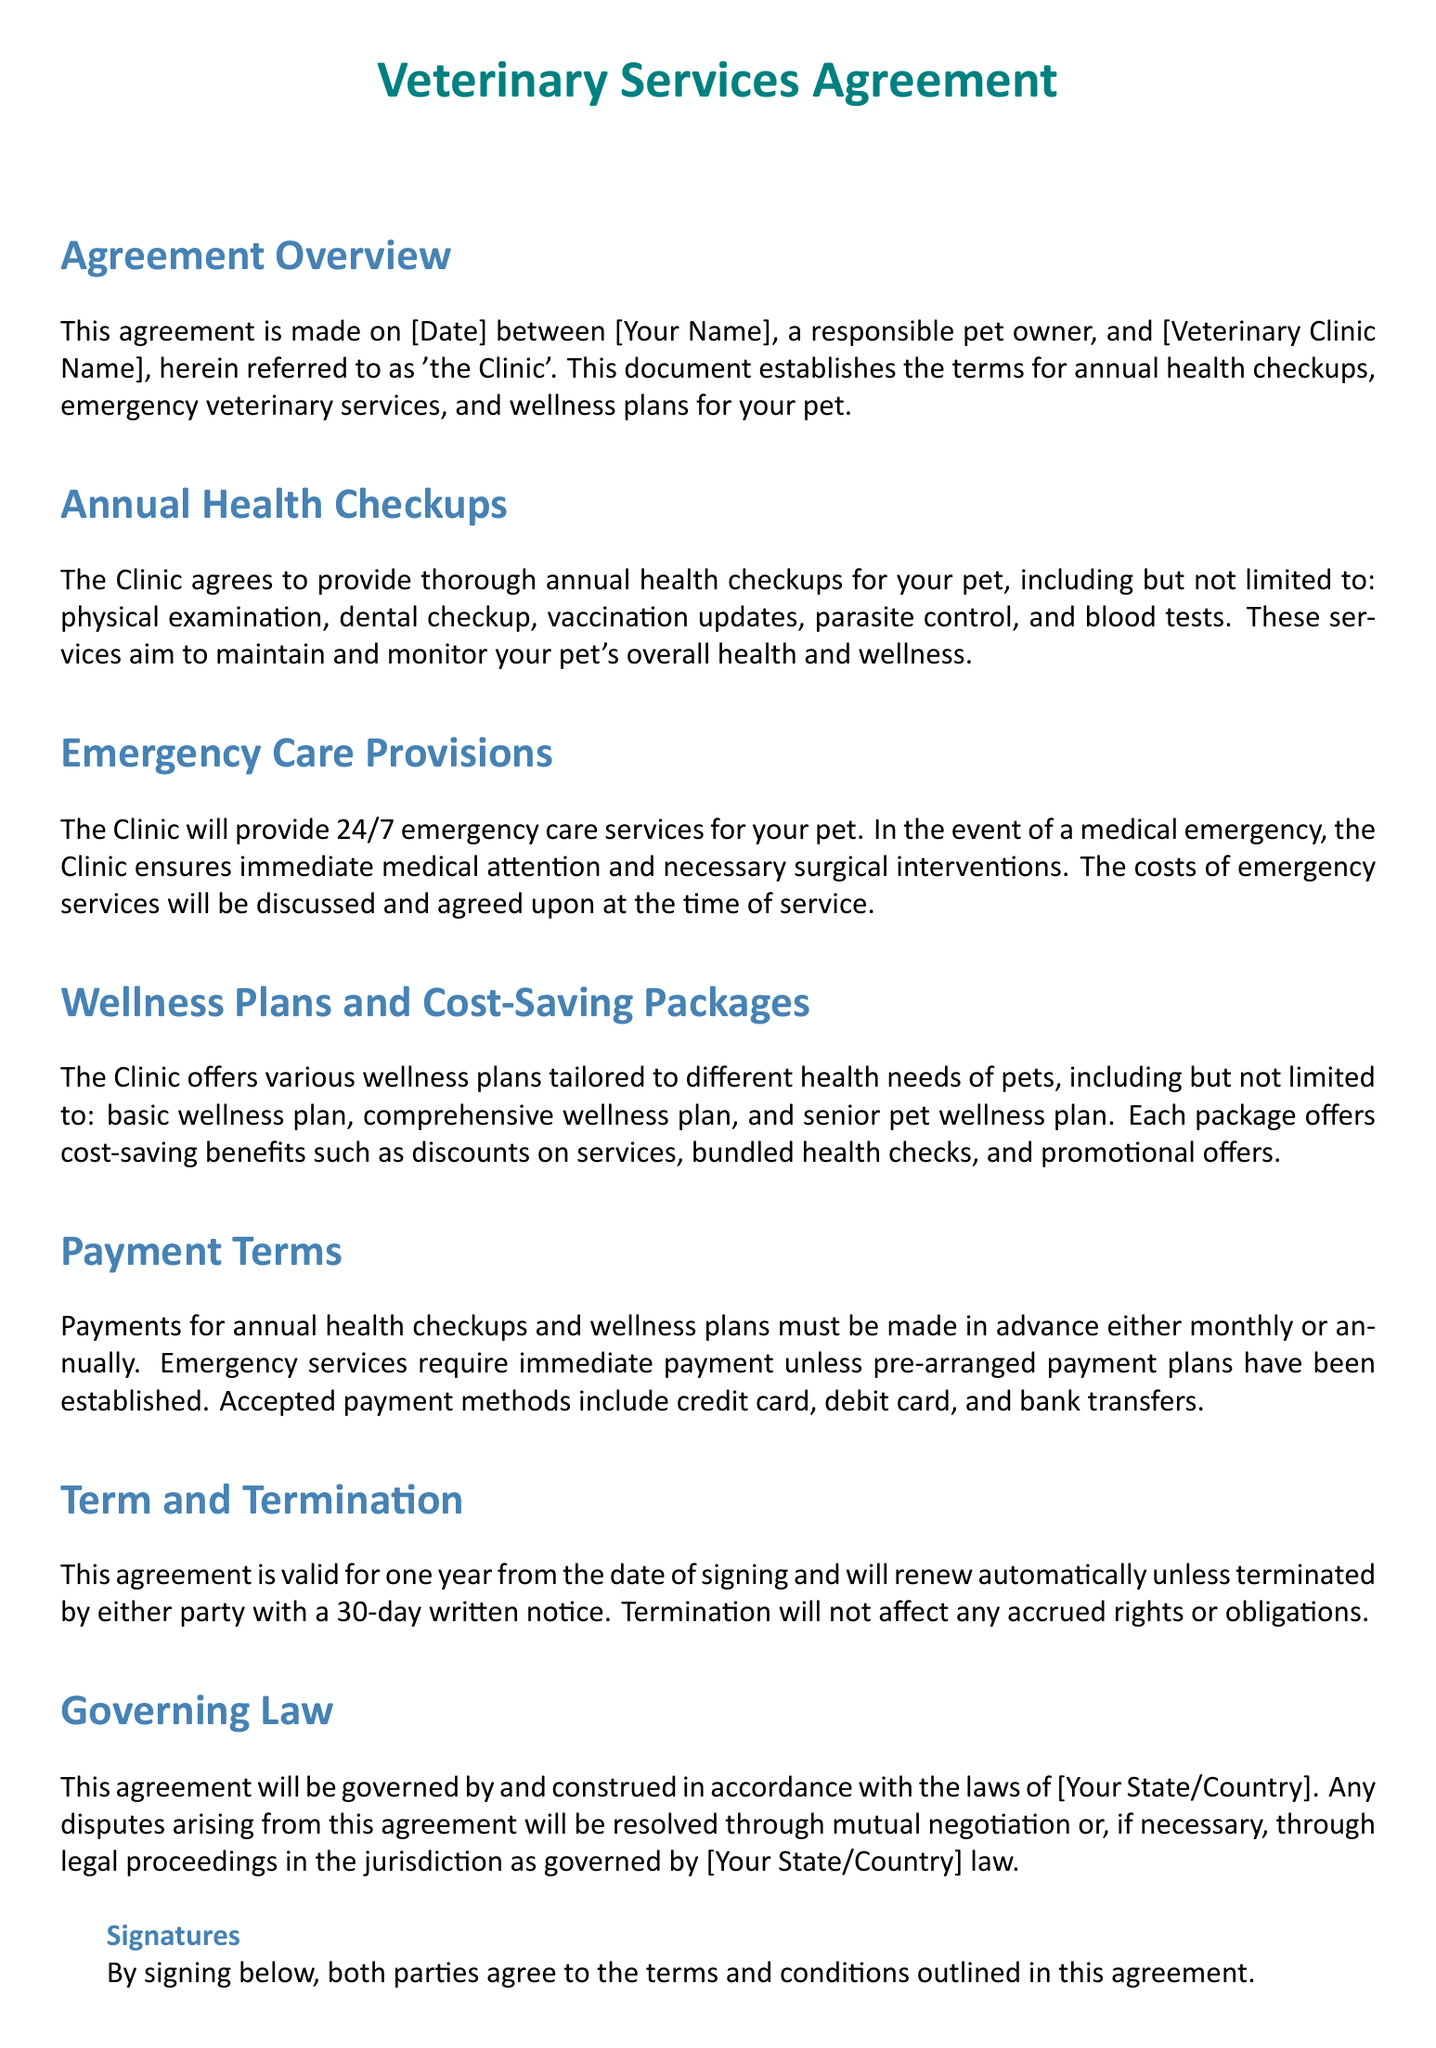What is the title of the document? The title of the document is stated at the top of the rendered document, which indicates the subject matter.
Answer: Veterinary Services Agreement Who is the responsible pet owner in the agreement? The pet owner's name is indicated in the agreement text where it outlines the parties involved.
Answer: [Your Name] What are the main services included in the annual health checkups? The document lists specific health services that are part of the annual checkup.
Answer: Physical examination, dental checkup, vaccination updates, parasite control, blood tests How often are payments for wellness plans due? The payment schedule is detailed in the payment terms section of the document.
Answer: Monthly or annually What type of care does the clinic provide for emergencies? The services offered during emergencies are specified in the document.
Answer: 24/7 emergency care What is the notice period required for termination of the agreement? The document specifies the amount of notice required for either party to terminate the agreement.
Answer: 30 days How long is the agreement valid? The validity period of the agreement is mentioned explicitly in the document.
Answer: One year What must be agreed upon at the time of emergency services? The document indicates an important aspect of emergency services related to financial agreements.
Answer: Costs of emergency services What is one of the wellness plans mentioned in the document? The document references specific types of wellness plans available for pets.
Answer: Basic wellness plan 